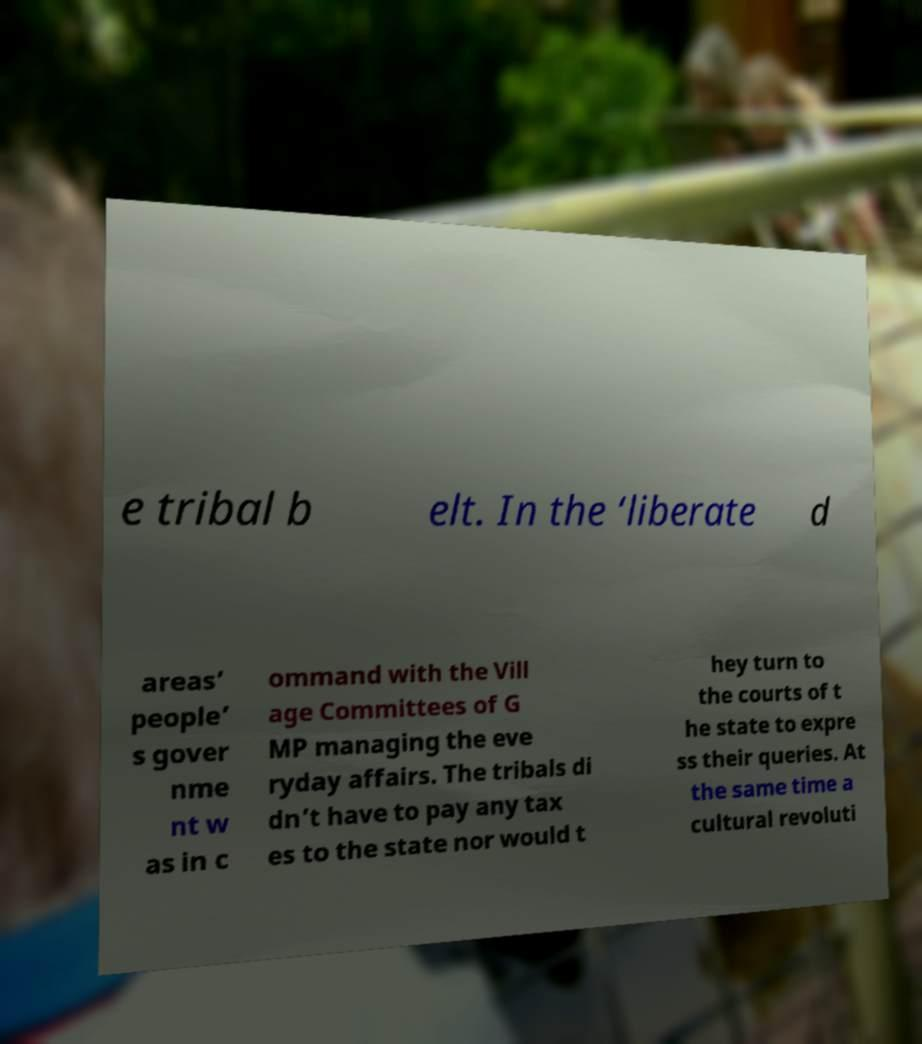Could you extract and type out the text from this image? e tribal b elt. In the ‘liberate d areas’ people’ s gover nme nt w as in c ommand with the Vill age Committees of G MP managing the eve ryday affairs. The tribals di dn’t have to pay any tax es to the state nor would t hey turn to the courts of t he state to expre ss their queries. At the same time a cultural revoluti 